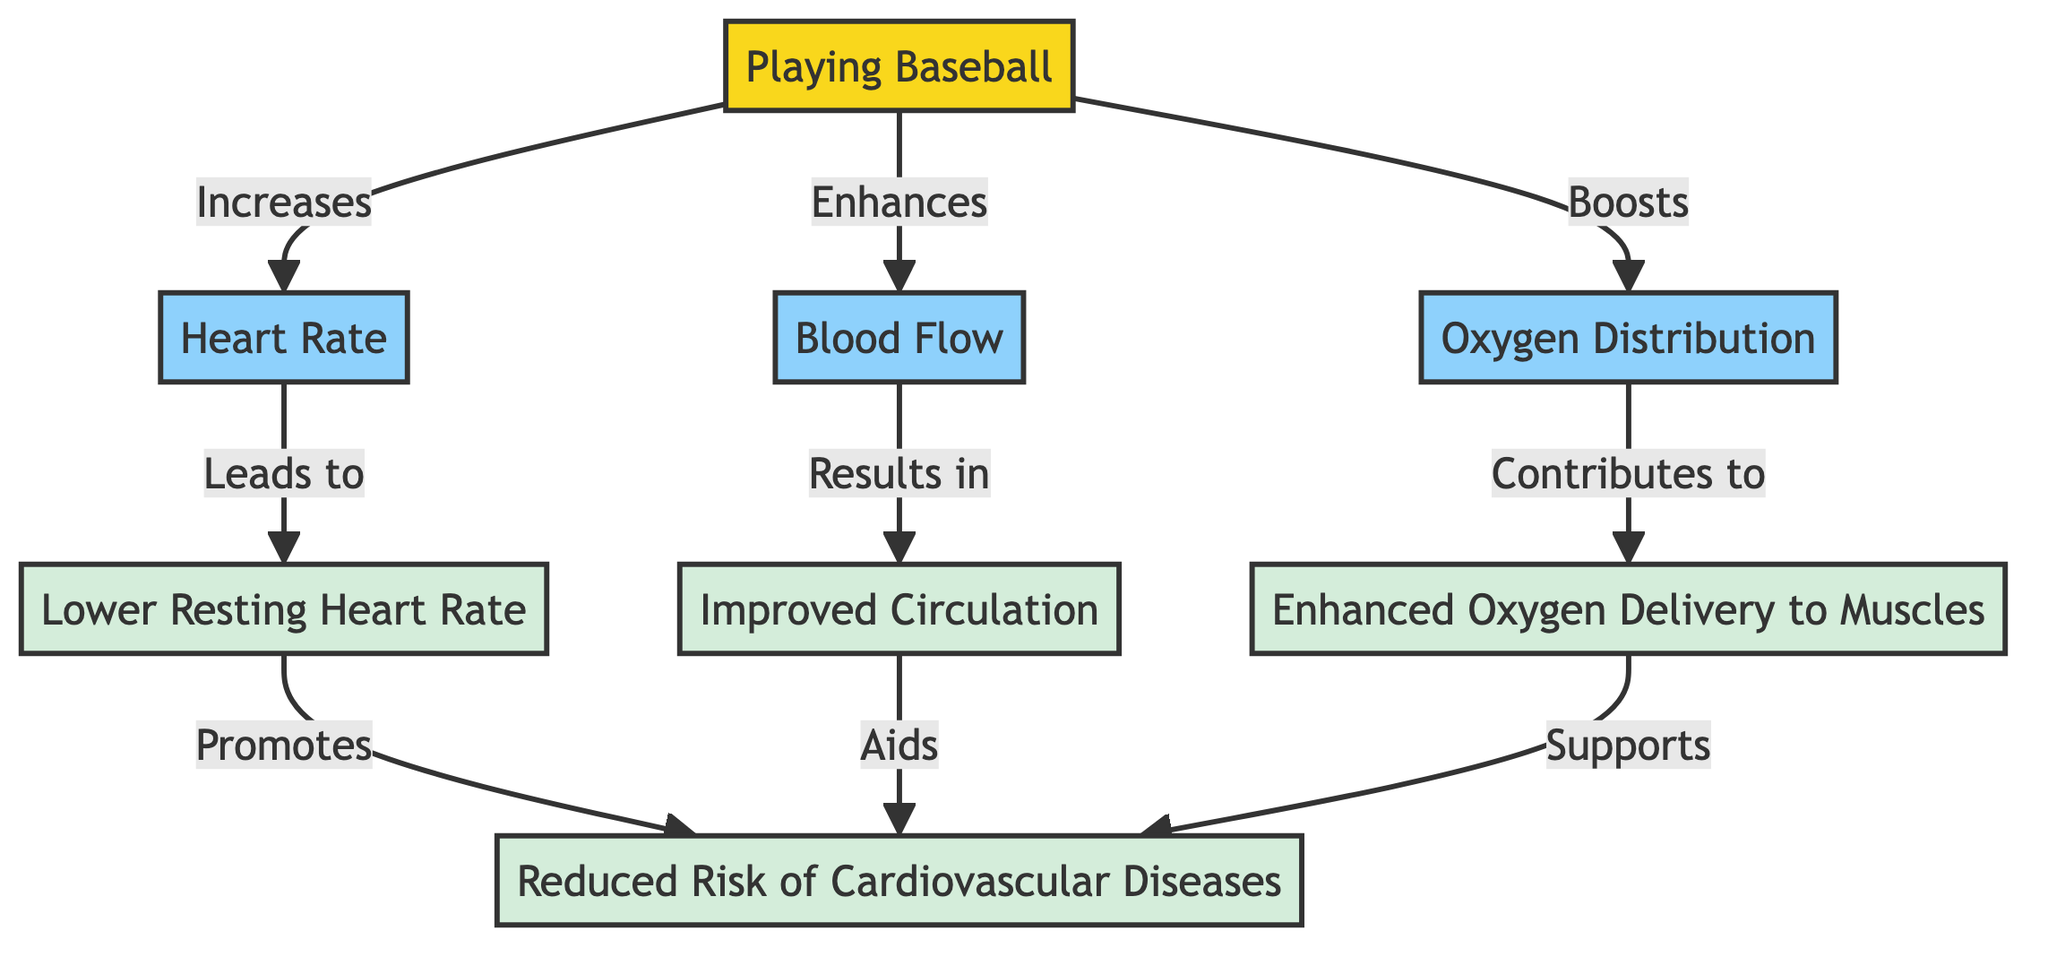What is the primary activity depicted in the diagram? The diagram starts with the node labeled "Playing Baseball," indicating that this is the central activity being considered for its cardiovascular health benefits.
Answer: Playing Baseball How many benefits of playing baseball are listed in the diagram? The diagram lists four benefits related to cardiovascular health, as seen in the nodes connected to the main activity.
Answer: Four What effect does playing baseball have on heart rate? The diagram states that playing baseball "Increases" heart rate, directly connecting the activity with this specific parameter.
Answer: Increases Which benefit is promoted by having a lower resting heart rate? The diagram indicates that a lower resting heart rate "Promotes" the benefit of "Reduced Risk of Cardiovascular Diseases," showing a direct correlation between these two nodes.
Answer: Reduced Risk of Cardiovascular Diseases What leads to improved circulation according to the diagram? The diagram specifies that enhanced blood flow results in improved circulation, establishing a clear cause-and-effect relationship.
Answer: Enhanced Blood Flow How does enhanced oxygen delivery to muscles relate to playing baseball? The diagram indicates that improved oxygen delivery to muscles is a consequence of playing baseball, as it shows the pathway from the activity to this particular benefit.
Answer: Boosts What is the main benefit associated with enhanced blood flow? According to the diagram, improved circulation is the main benefit associated with enhanced blood flow, creating a direct linkage between these concepts.
Answer: Improved Circulation Is "Oxygen Distribution" directly connected to a benefit in the diagram? Yes, the diagram illustrates that improved oxygen distribution contributes to enhanced oxygen delivery to muscles, indicating that it is directly connected to a beneficial outcome.
Answer: Contributes to Enhanced Oxygen Delivery to Muscles Which specific benefit is italicized in the diagram? The benefit "Reduced Risk of Cardiovascular Diseases" is emphasized by being italicized, indicating its significance among the listed benefits.
Answer: Reduced Risk of Cardiovascular Diseases 